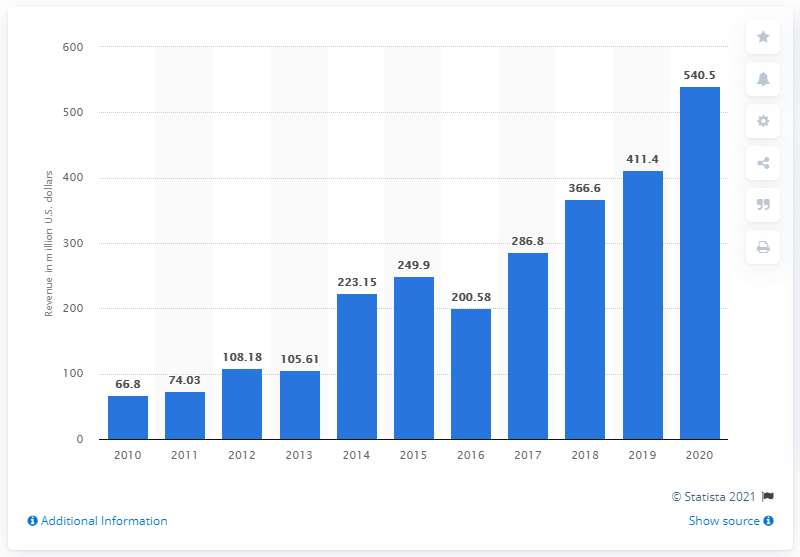Specify some key components in this picture. Glu Mobile's revenue a year earlier was approximately 411.4 million. In 2020, Glu Mobile's revenue was $540.5 million. 